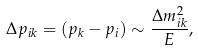<formula> <loc_0><loc_0><loc_500><loc_500>\Delta p _ { i k } = ( p _ { k } - p _ { i } ) \sim \frac { \Delta m ^ { 2 } _ { i k } } { E } ,</formula> 